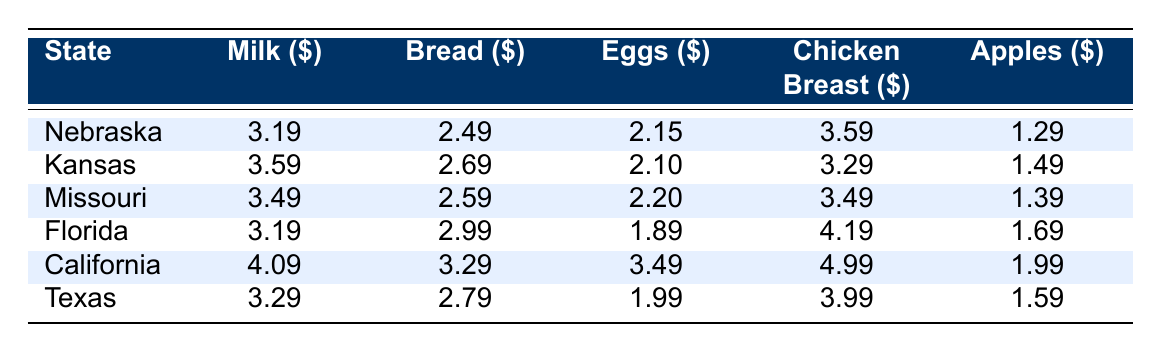What is the average price of milk in landlocked states? In the table, landlocked states are Nebraska, Kansas, and Missouri. The prices are 3.19, 3.59, and 3.49 respectively. To find the average, I sum these values: 3.19 + 3.59 + 3.49 = 10.27, then divide by 3 (the number of states), resulting in 10.27 / 3 = 3.4233. Rounding to two decimal places, the average is 3.42.
Answer: 3.42 Which state has the highest average price for chicken breast? Looking at the chicken breast prices, Florida has a price of 4.19, California has 4.99, Texas has 3.99, Nebraska has 3.59, Kansas has 3.29, and Missouri has 3.49. The highest value is 4.99 from California.
Answer: California Is the average price of eggs higher in coastal states compared to landlocked states? The average price of eggs for landlocked states (Nebraska, Kansas, Missouri) is (2.15 + 2.10 + 2.20) / 3 = 2.15. For coastal states (Florida, California, Texas), the average is (1.89 + 3.49 + 1.99) / 3 = 2.79. Since 2.79 is higher than 2.15, the statement is true.
Answer: Yes What is the price difference of apples between the cheapest (landlocked) and the most expensive (coastal) states? The cheapest price for apples is 1.29 in Nebraska, and the most expensive is 1.99 in California. The difference is 1.99 - 1.29 = 0.70.
Answer: 0.70 What is the average price of bread in coastal states? The coastal states are Florida, California, and Texas with bread prices of 2.99, 3.29, and 2.79, respectively. To calculate the average, I sum these values: 2.99 + 3.29 + 2.79 = 9.07, then divide by 3 (the number of states), resulting in 9.07 / 3 = 3.0233. Rounding to two decimal places, the average is 3.02.
Answer: 3.02 